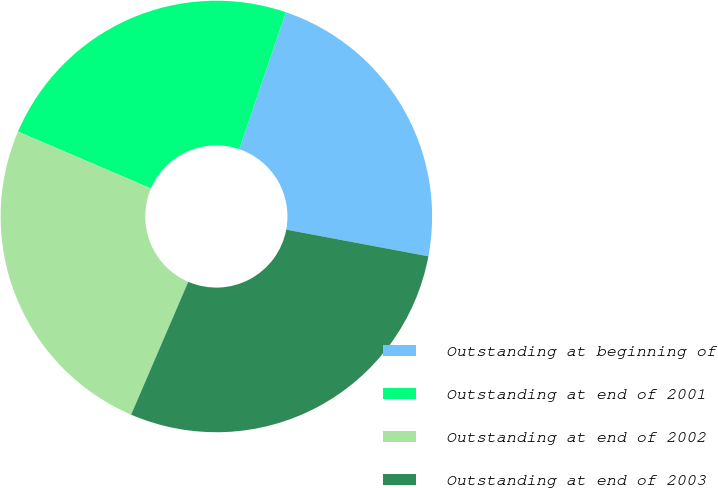Convert chart to OTSL. <chart><loc_0><loc_0><loc_500><loc_500><pie_chart><fcel>Outstanding at beginning of<fcel>Outstanding at end of 2001<fcel>Outstanding at end of 2002<fcel>Outstanding at end of 2003<nl><fcel>22.73%<fcel>23.79%<fcel>24.97%<fcel>28.51%<nl></chart> 